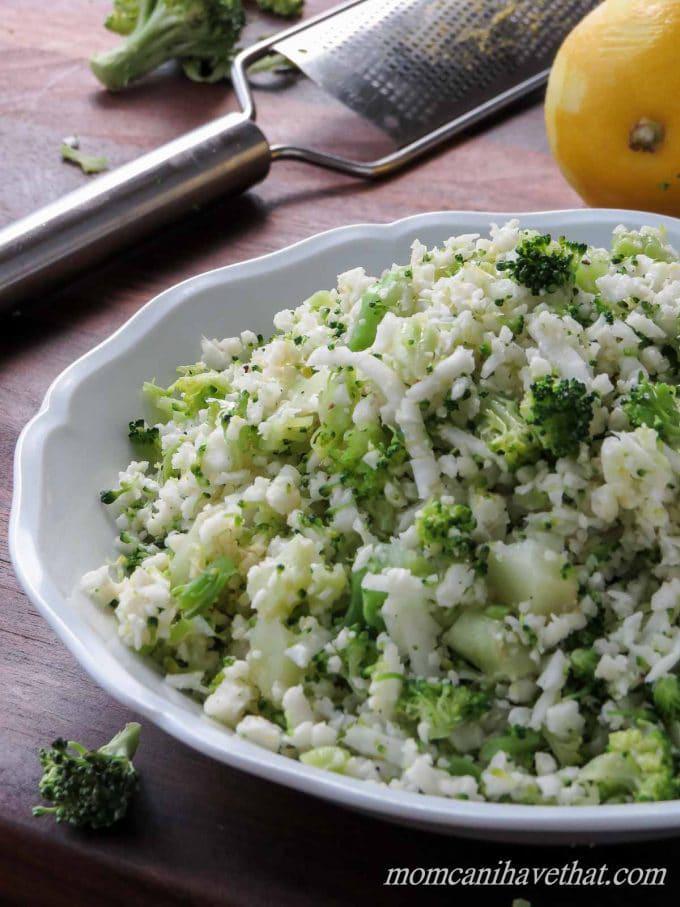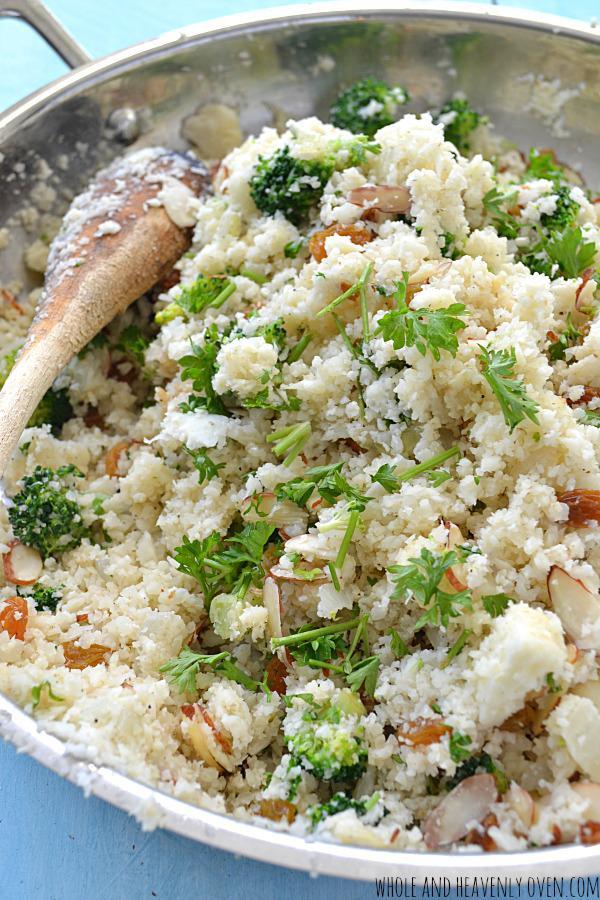The first image is the image on the left, the second image is the image on the right. Assess this claim about the two images: "the rice on the left image is on a white plate". Correct or not? Answer yes or no. Yes. 